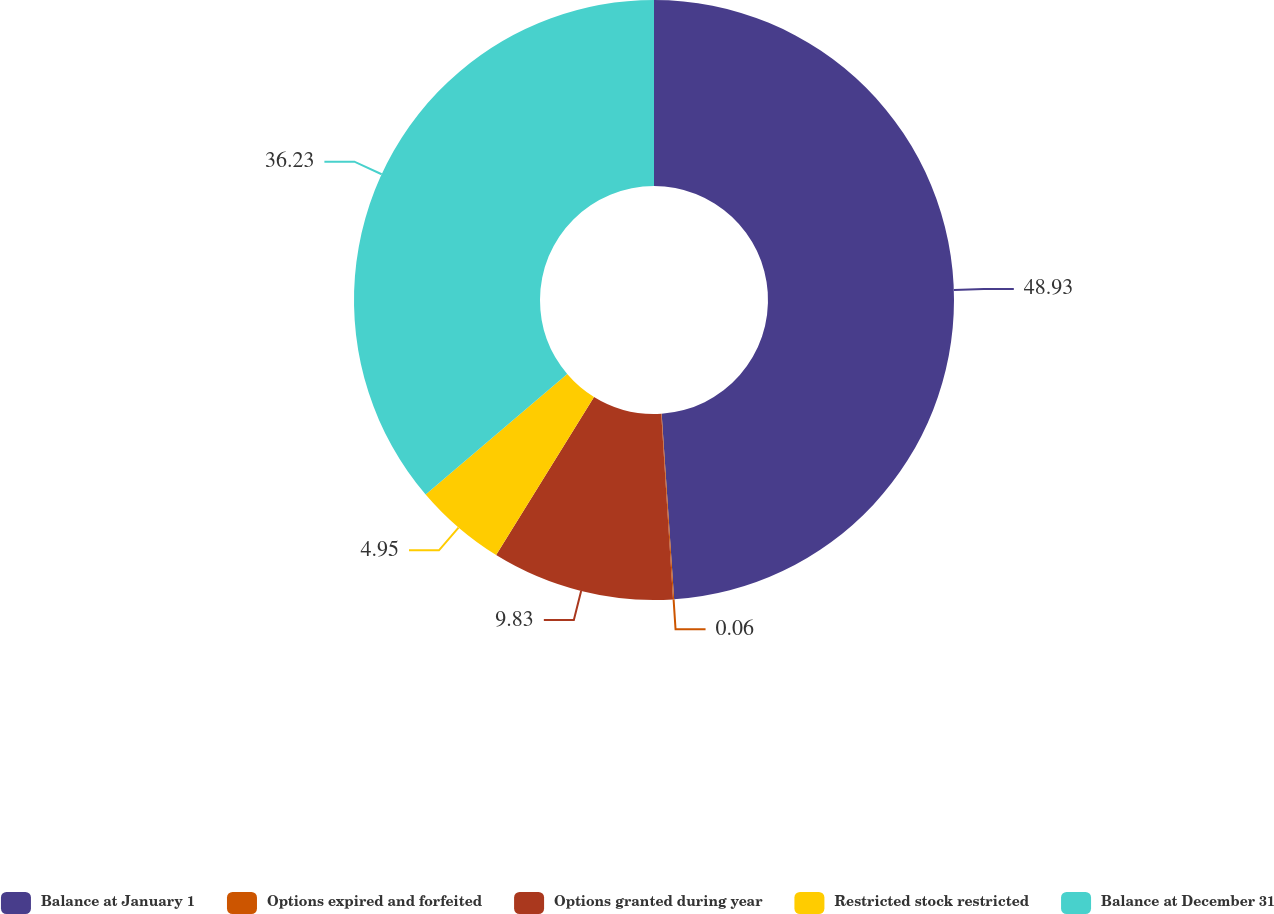Convert chart. <chart><loc_0><loc_0><loc_500><loc_500><pie_chart><fcel>Balance at January 1<fcel>Options expired and forfeited<fcel>Options granted during year<fcel>Restricted stock restricted<fcel>Balance at December 31<nl><fcel>48.93%<fcel>0.06%<fcel>9.83%<fcel>4.95%<fcel>36.23%<nl></chart> 